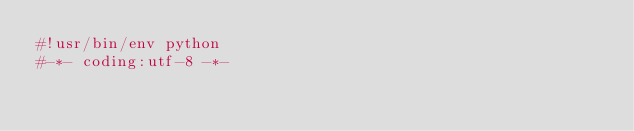Convert code to text. <code><loc_0><loc_0><loc_500><loc_500><_Python_>#!usr/bin/env python
#-*- coding:utf-8 -*-

</code> 